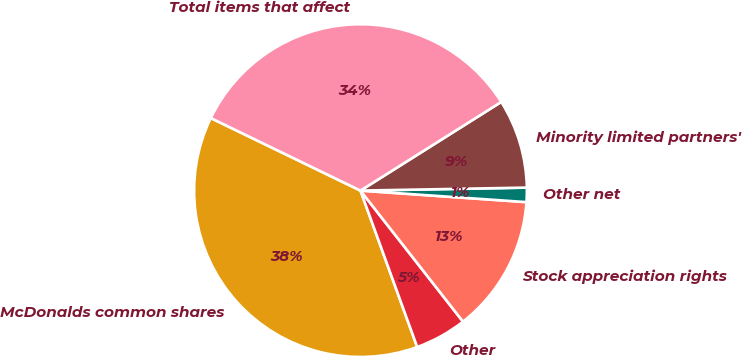<chart> <loc_0><loc_0><loc_500><loc_500><pie_chart><fcel>McDonalds common shares<fcel>Other<fcel>Stock appreciation rights<fcel>Other net<fcel>Minority limited partners'<fcel>Total items that affect<nl><fcel>37.72%<fcel>5.03%<fcel>13.33%<fcel>1.39%<fcel>8.66%<fcel>33.87%<nl></chart> 